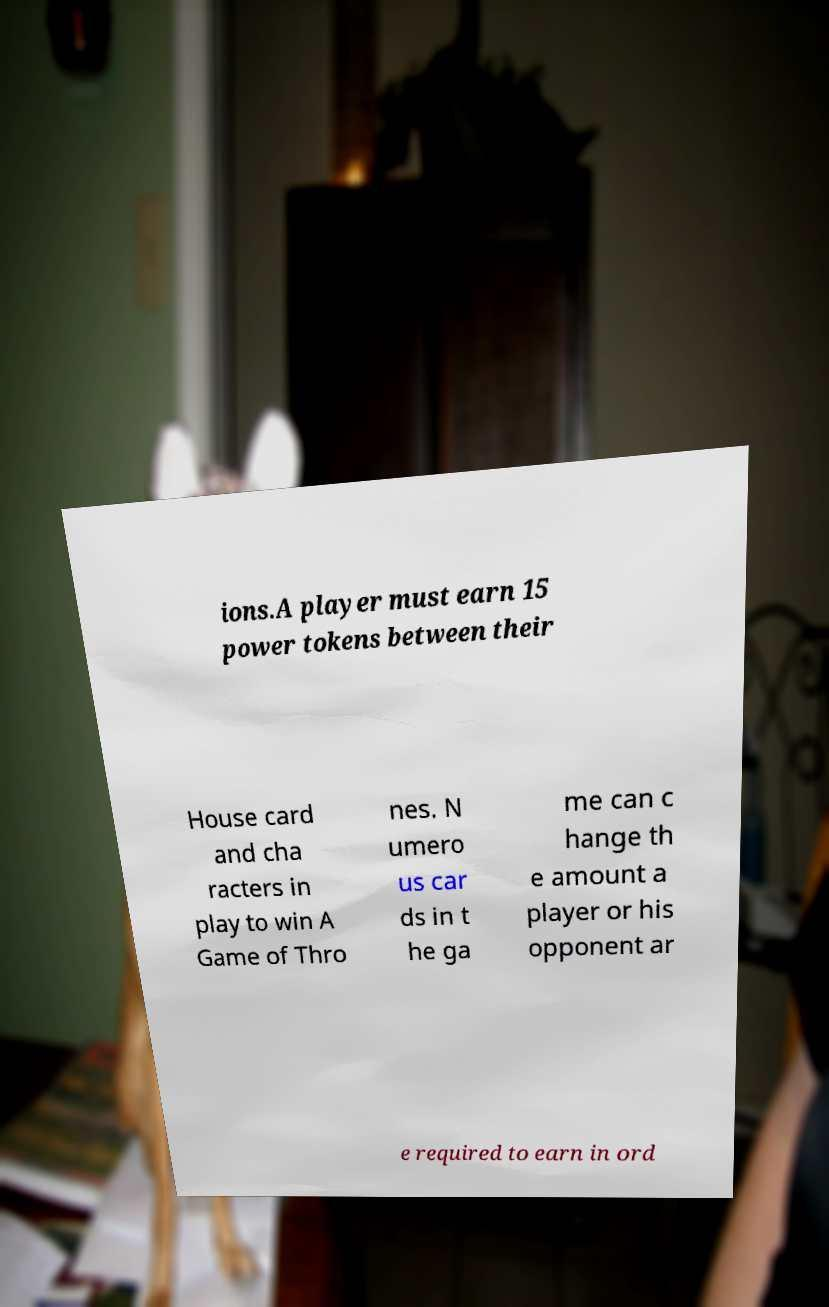Could you extract and type out the text from this image? ions.A player must earn 15 power tokens between their House card and cha racters in play to win A Game of Thro nes. N umero us car ds in t he ga me can c hange th e amount a player or his opponent ar e required to earn in ord 